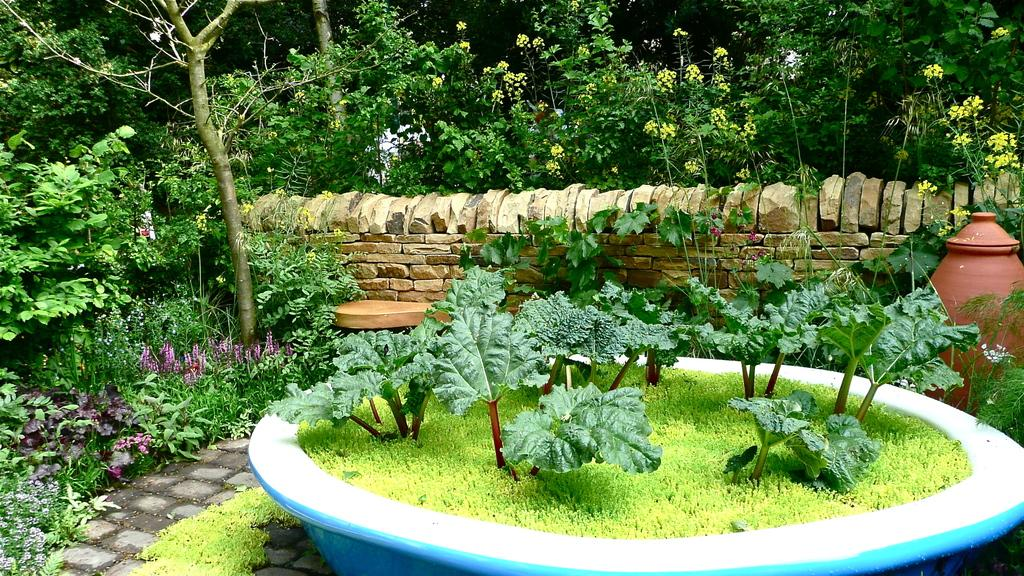What type of living organisms can be seen in the image? Plants can be seen in the image. What is the pot used for in the image? The pot is likely used to hold the plants in the image. What type of material is present in the image? Stones are present in the image. Can you describe any other objects in the image? There are some objects in the image, but their specific purpose is not clear. What can be seen in the background of the image? Trees are visible in the background of the image. What type of card is being used to poison the plants in the image? There is no card or poison present in the image; it features plants in a pot with stones and other objects. 